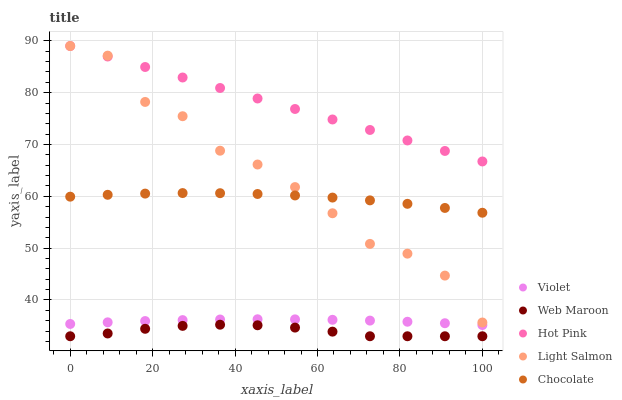Does Web Maroon have the minimum area under the curve?
Answer yes or no. Yes. Does Hot Pink have the maximum area under the curve?
Answer yes or no. Yes. Does Light Salmon have the minimum area under the curve?
Answer yes or no. No. Does Light Salmon have the maximum area under the curve?
Answer yes or no. No. Is Hot Pink the smoothest?
Answer yes or no. Yes. Is Light Salmon the roughest?
Answer yes or no. Yes. Is Light Salmon the smoothest?
Answer yes or no. No. Is Hot Pink the roughest?
Answer yes or no. No. Does Web Maroon have the lowest value?
Answer yes or no. Yes. Does Light Salmon have the lowest value?
Answer yes or no. No. Does Hot Pink have the highest value?
Answer yes or no. Yes. Does Web Maroon have the highest value?
Answer yes or no. No. Is Violet less than Hot Pink?
Answer yes or no. Yes. Is Hot Pink greater than Web Maroon?
Answer yes or no. Yes. Does Light Salmon intersect Hot Pink?
Answer yes or no. Yes. Is Light Salmon less than Hot Pink?
Answer yes or no. No. Is Light Salmon greater than Hot Pink?
Answer yes or no. No. Does Violet intersect Hot Pink?
Answer yes or no. No. 